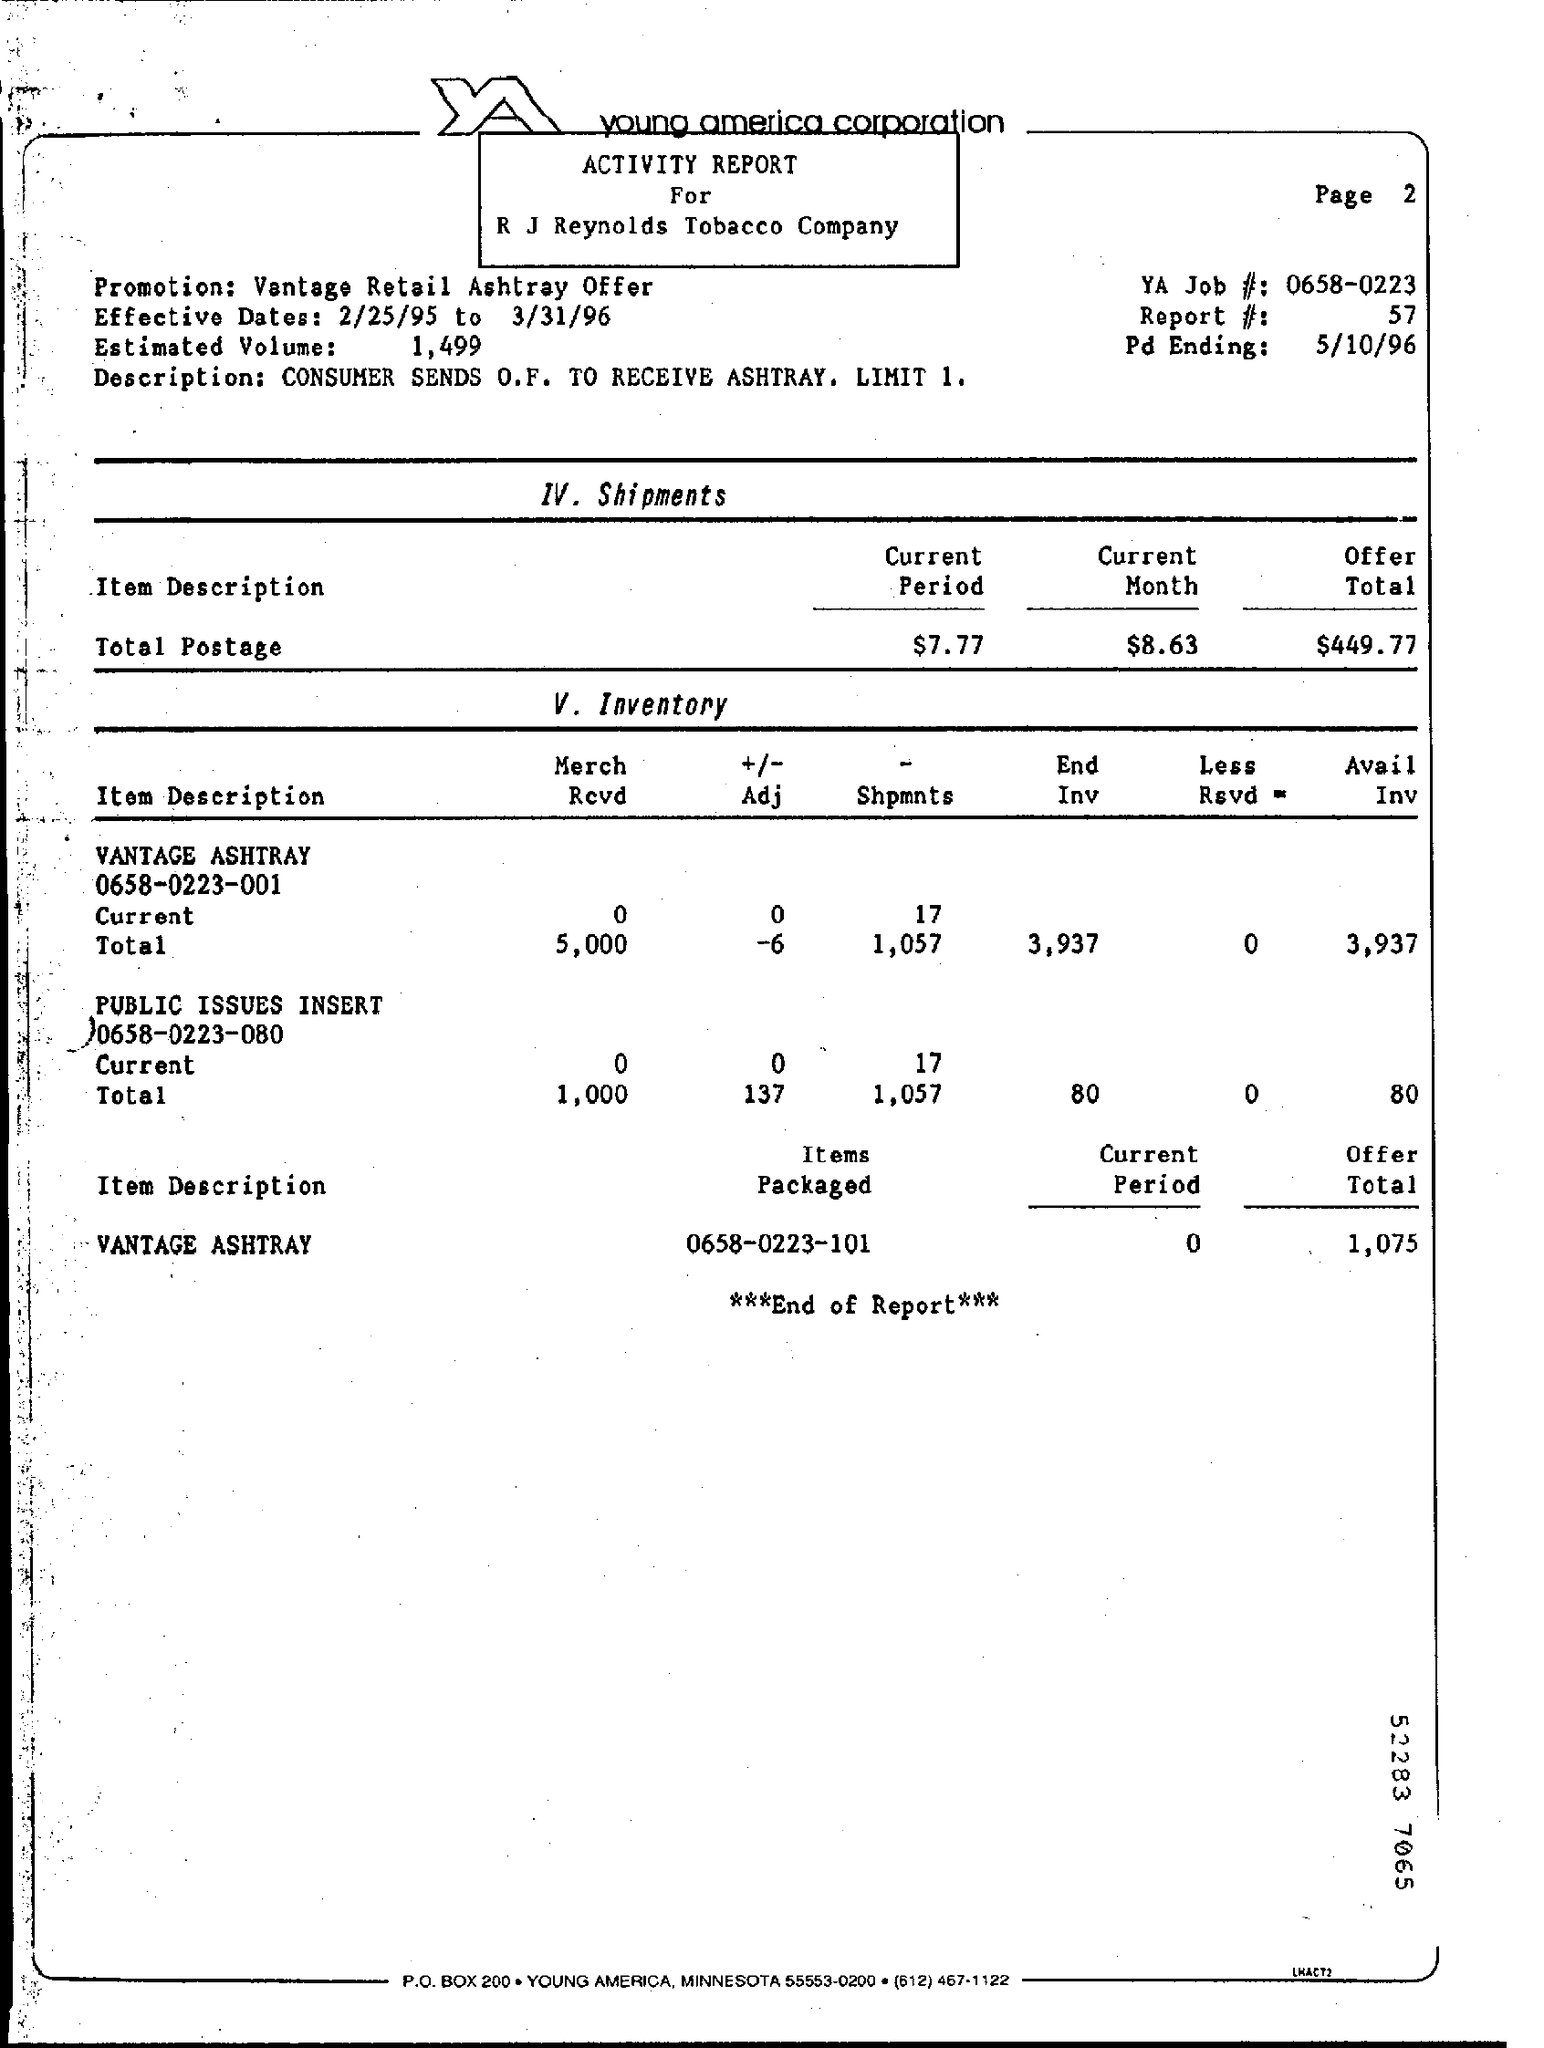Highlight a few significant elements in this photo. The estimated volume is 1,499... The YA job number is 0658-0223. The effective dates for a specific period of time are from February 25, 1995 to March 31, 1996. On May 10th, 1996, the Pd ending was revealed. We are pleased to offer our customers the opportunity to enjoy the premium Vantage Retail Ashtray with their purchase. 